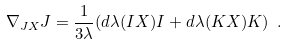Convert formula to latex. <formula><loc_0><loc_0><loc_500><loc_500>\nabla _ { J X } J = \frac { 1 } { 3 \lambda } ( d \lambda ( I X ) I + d \lambda ( K X ) K ) \ .</formula> 